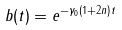<formula> <loc_0><loc_0><loc_500><loc_500>b ( t ) = e ^ { - \gamma _ { 0 } ( 1 + 2 n ) t }</formula> 